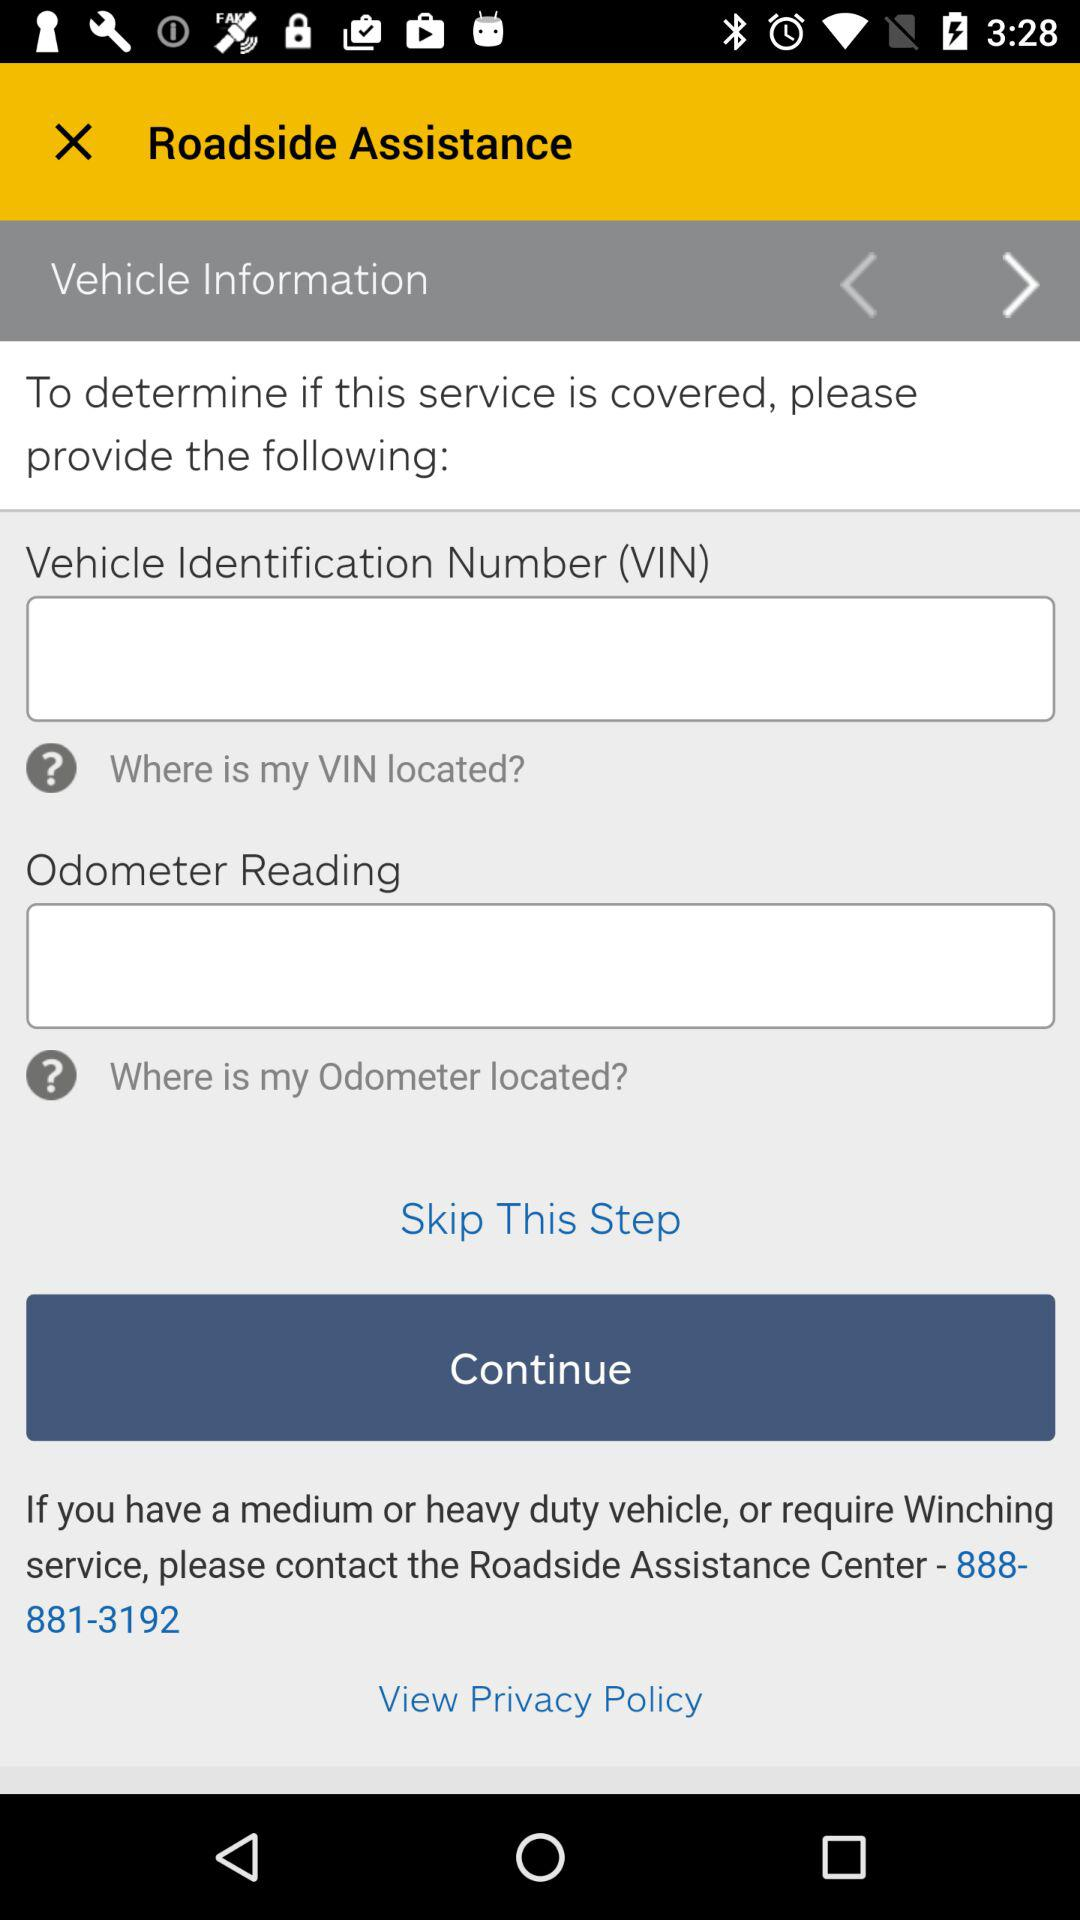How many input fields does this form have?
Answer the question using a single word or phrase. 2 